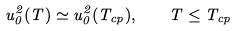<formula> <loc_0><loc_0><loc_500><loc_500>u _ { 0 } ^ { 2 } ( T ) \simeq u _ { 0 } ^ { 2 } ( T _ { c p } ) , \quad T \leq T _ { c p }</formula> 